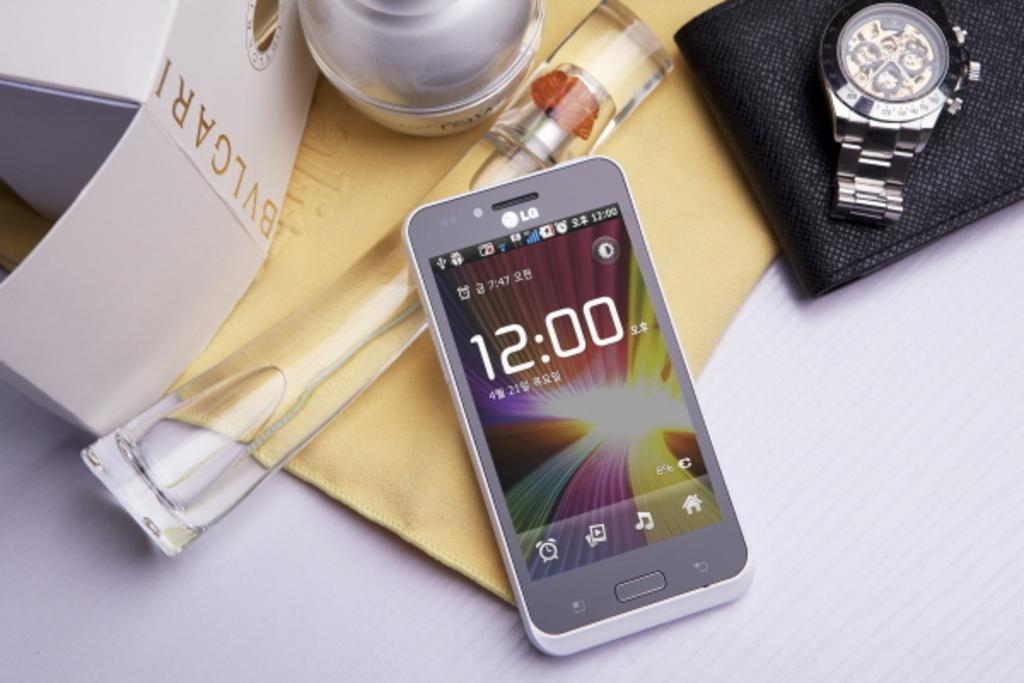<image>
Offer a succinct explanation of the picture presented. An LG cell phone laying on a table with an expensive watch and a bottle of BVLGARI perfume. 